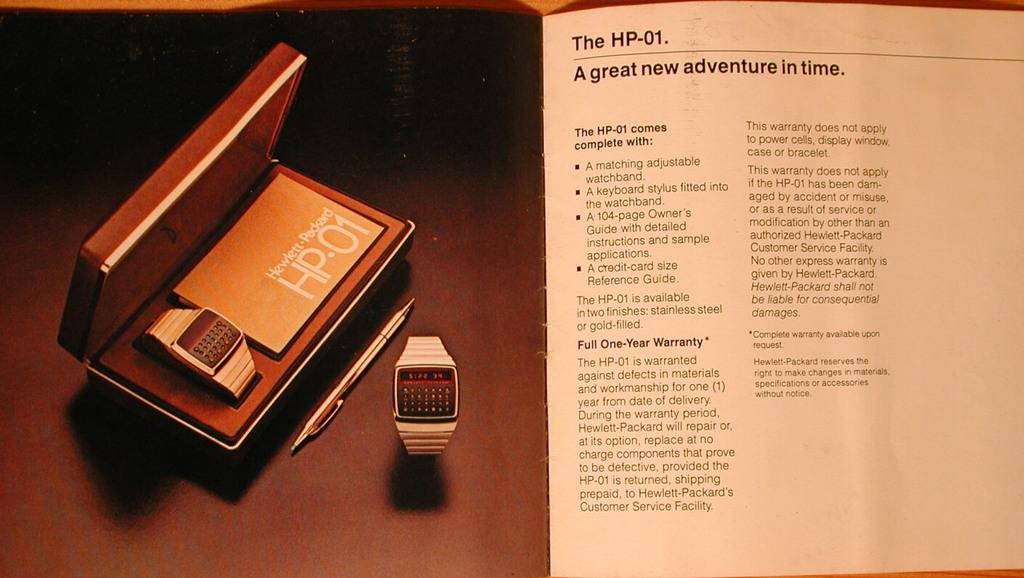<image>
Write a terse but informative summary of the picture. a box containing an HP-01 smart watch with an instruction manual on the right side. 